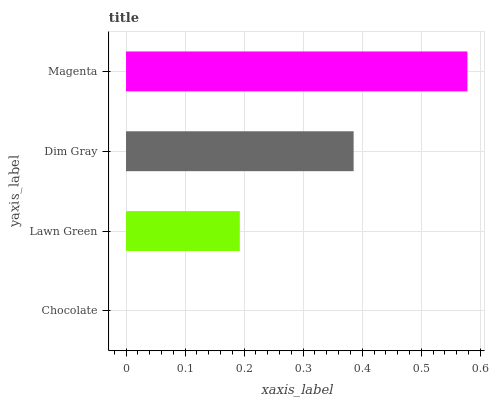Is Chocolate the minimum?
Answer yes or no. Yes. Is Magenta the maximum?
Answer yes or no. Yes. Is Lawn Green the minimum?
Answer yes or no. No. Is Lawn Green the maximum?
Answer yes or no. No. Is Lawn Green greater than Chocolate?
Answer yes or no. Yes. Is Chocolate less than Lawn Green?
Answer yes or no. Yes. Is Chocolate greater than Lawn Green?
Answer yes or no. No. Is Lawn Green less than Chocolate?
Answer yes or no. No. Is Dim Gray the high median?
Answer yes or no. Yes. Is Lawn Green the low median?
Answer yes or no. Yes. Is Magenta the high median?
Answer yes or no. No. Is Chocolate the low median?
Answer yes or no. No. 